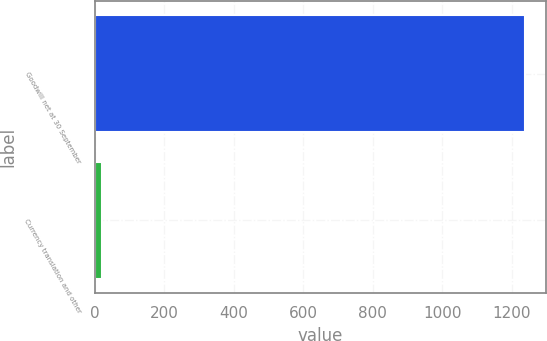<chart> <loc_0><loc_0><loc_500><loc_500><bar_chart><fcel>Goodwill net at 30 September<fcel>Currency translation and other<nl><fcel>1237.3<fcel>19.9<nl></chart> 